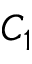Convert formula to latex. <formula><loc_0><loc_0><loc_500><loc_500>C _ { 1 }</formula> 